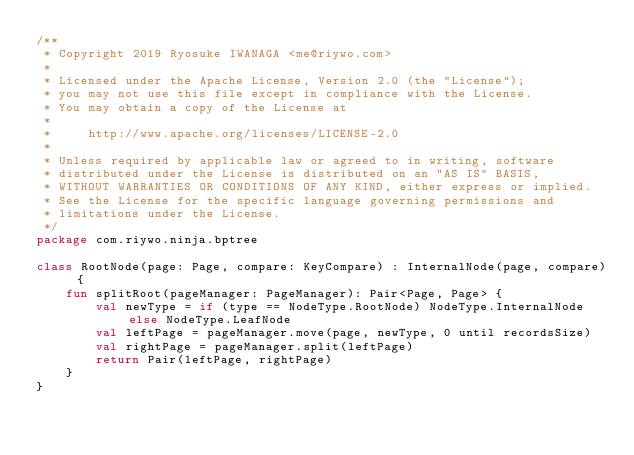Convert code to text. <code><loc_0><loc_0><loc_500><loc_500><_Kotlin_>/**
 * Copyright 2019 Ryosuke IWANAGA <me@riywo.com>
 *
 * Licensed under the Apache License, Version 2.0 (the "License");
 * you may not use this file except in compliance with the License.
 * You may obtain a copy of the License at
 *
 *     http://www.apache.org/licenses/LICENSE-2.0
 *
 * Unless required by applicable law or agreed to in writing, software
 * distributed under the License is distributed on an "AS IS" BASIS,
 * WITHOUT WARRANTIES OR CONDITIONS OF ANY KIND, either express or implied.
 * See the License for the specific language governing permissions and
 * limitations under the License.
 */
package com.riywo.ninja.bptree

class RootNode(page: Page, compare: KeyCompare) : InternalNode(page, compare) {
    fun splitRoot(pageManager: PageManager): Pair<Page, Page> {
        val newType = if (type == NodeType.RootNode) NodeType.InternalNode else NodeType.LeafNode
        val leftPage = pageManager.move(page, newType, 0 until recordsSize)
        val rightPage = pageManager.split(leftPage)
        return Pair(leftPage, rightPage)
    }
}</code> 